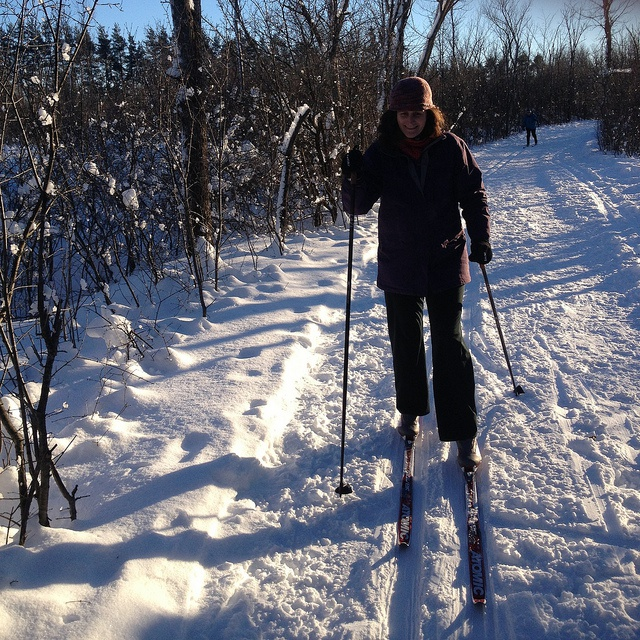Describe the objects in this image and their specific colors. I can see people in gray, black, and darkgray tones, skis in gray, black, navy, and darkgray tones, and people in gray and black tones in this image. 